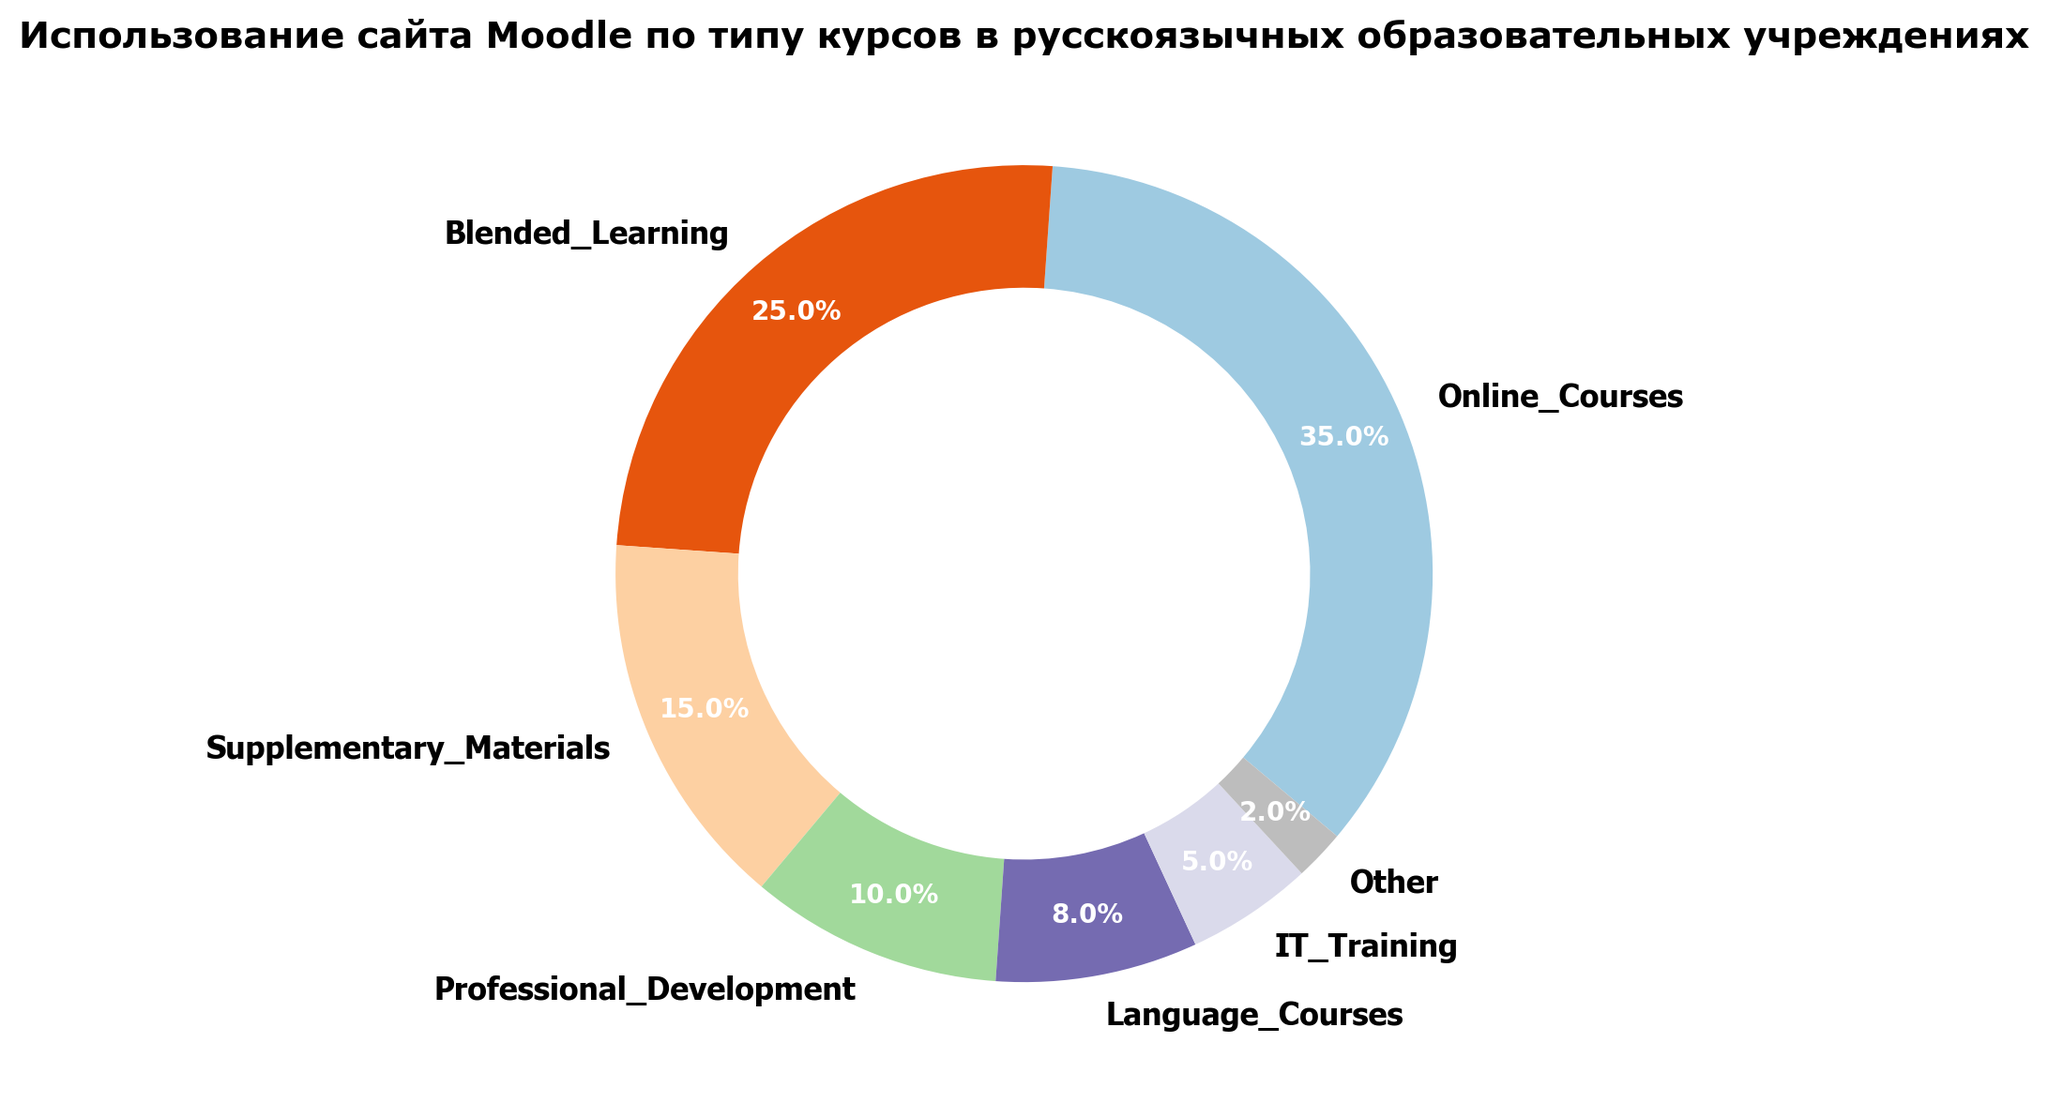Какой тип курсов занимает наибольшую долю использования сайта Moodle? Найдите курс с наибольшим процентом использования. Это Online_Courses с 35%.
Answer: Online_Courses Какая разница в проценте использования между курсами Online_Courses и Blended_Learning? Процент использования Online_Courses составляет 35%, а Blended_Learning - 25%. Разница составляет 35% - 25% = 10%.
Answer: 10% Сколько процентов составляют вместе Supplementary_Materials и Professional_Development? Процент использования Supplementary_Materials равен 15%, а Professional_Development - 10%. Сложим их вместе: 15% + 10% = 25%.
Answer: 25% Тренеровок по ИТ больше или меньше, чем языковых курсов, и на сколько? Процент использования IT_Training равен 5%, а Language_Courses - 8%. IT_Training меньше на 8% - 5% = 3%.
Answer: Меньше на 3% Какую общую долю составляют Blended_Learning, Supplementary_Materials и Language_Courses? Процент использования Blended_Learning, Supplementary_Materials и Language_Courses: 25%, 15% и 8% соответственно. Сложим их: 25% + 15% + 8% = 48%.
Answer: 48% Какой курс занимает наименьшую долю использования? Найдите курс с наименьшим процентом использования. Это Other с 2%.
Answer: Other Какая объединенная доля использования курсов Online_Courses и IT_Training? Процент использования Online_Courses равен 35%, а IT_Training - 5%. Сложим их: 35% + 5% = 40%.
Answer: 40% Какой цвет наиболее визуально выделяется в диаграмме? Визуально оцените диаграмму и выберите наиболее яркий/доминирующий цвет. Обычно это цвет сегмента с самым большим процентом, что соответствует Online_Courses.
Answer: Цвет сегмента Online_Courses Какая общая доля курсов, не относящихся к основной образовательной деятельности (Blended_Learning, Supplementary_Materials)? Процент использования Blended_Learning равен 25%, а Supplementary_Materials - 15%. Сложим их: 25% + 15% = 40%.
Answer: 40% Какие два самых малопопулярных типа курсов и их суммарная доля? Проанализировав проценты, наименьшие два процента у Other (2%) и IT_Training (5%). Их суммарная доля составляет 2% + 5% = 7%.
Answer: Other и IT_Training, 7% 